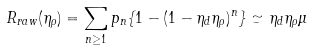Convert formula to latex. <formula><loc_0><loc_0><loc_500><loc_500>R _ { r a w } ( \eta _ { \rho } ) = \sum _ { n \geq 1 } p _ { n } \{ 1 - ( 1 - \eta _ { d } \eta _ { \rho } ) ^ { n } \} \simeq \eta _ { d } \eta _ { \rho } \mu</formula> 